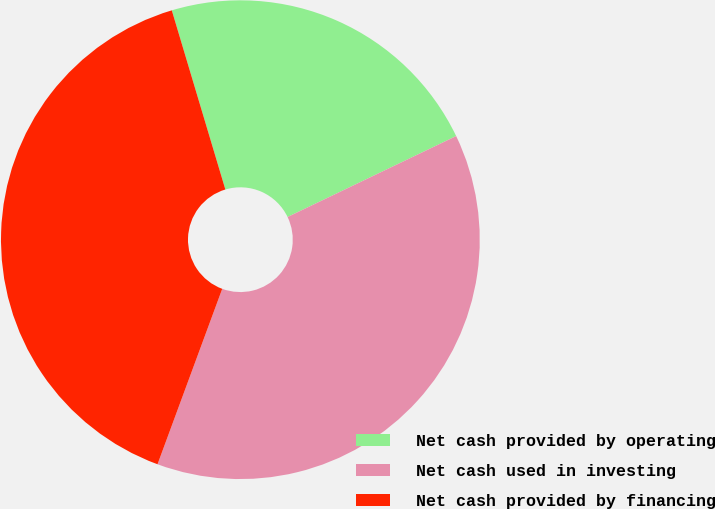<chart> <loc_0><loc_0><loc_500><loc_500><pie_chart><fcel>Net cash provided by operating<fcel>Net cash used in investing<fcel>Net cash provided by financing<nl><fcel>22.5%<fcel>37.75%<fcel>39.75%<nl></chart> 